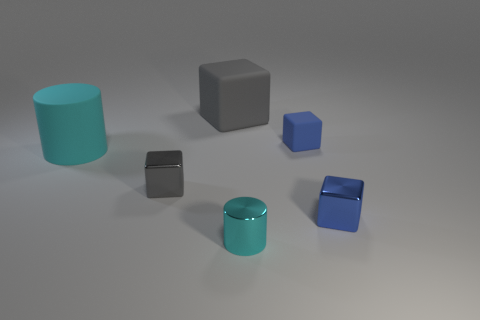Subtract all gray matte blocks. How many blocks are left? 3 Add 1 matte objects. How many objects exist? 7 Subtract all blue blocks. How many blocks are left? 2 Subtract all cylinders. How many objects are left? 4 Subtract all green cubes. Subtract all brown cylinders. How many cubes are left? 4 Subtract all green balls. How many yellow cylinders are left? 0 Subtract all yellow rubber spheres. Subtract all small blocks. How many objects are left? 3 Add 2 gray objects. How many gray objects are left? 4 Add 4 small metallic things. How many small metallic things exist? 7 Subtract 0 yellow cylinders. How many objects are left? 6 